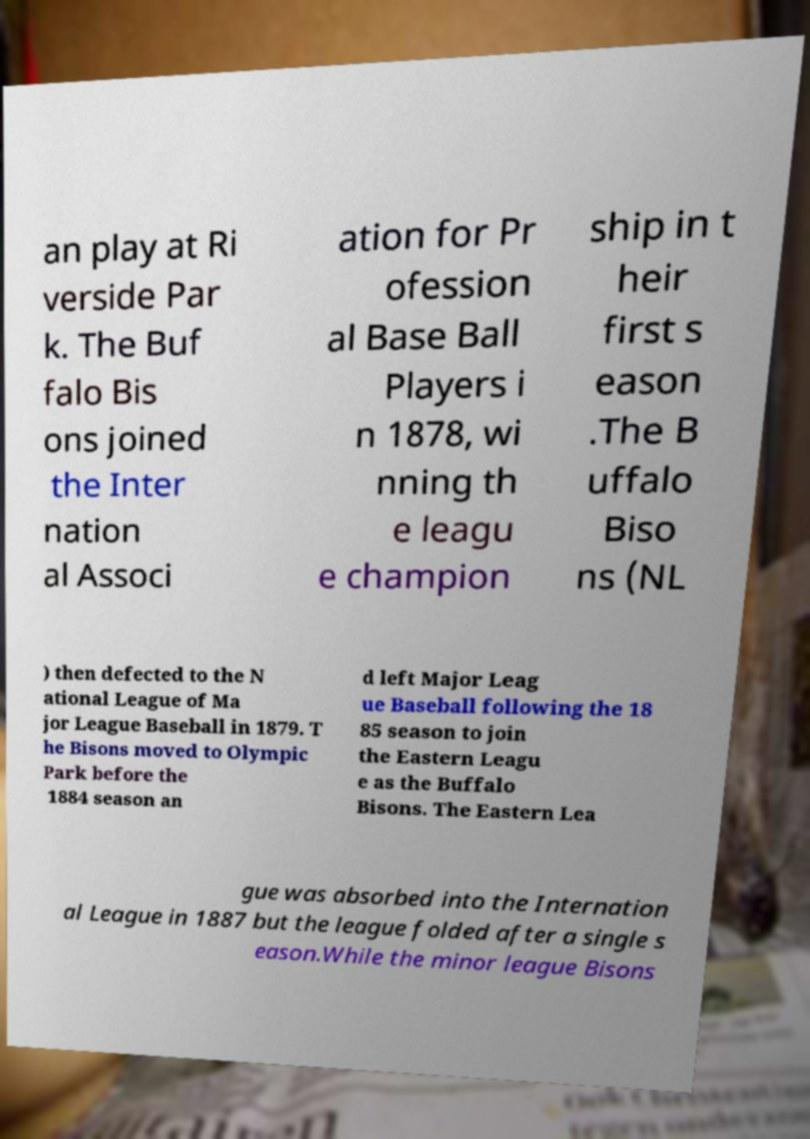I need the written content from this picture converted into text. Can you do that? an play at Ri verside Par k. The Buf falo Bis ons joined the Inter nation al Associ ation for Pr ofession al Base Ball Players i n 1878, wi nning th e leagu e champion ship in t heir first s eason .The B uffalo Biso ns (NL ) then defected to the N ational League of Ma jor League Baseball in 1879. T he Bisons moved to Olympic Park before the 1884 season an d left Major Leag ue Baseball following the 18 85 season to join the Eastern Leagu e as the Buffalo Bisons. The Eastern Lea gue was absorbed into the Internation al League in 1887 but the league folded after a single s eason.While the minor league Bisons 